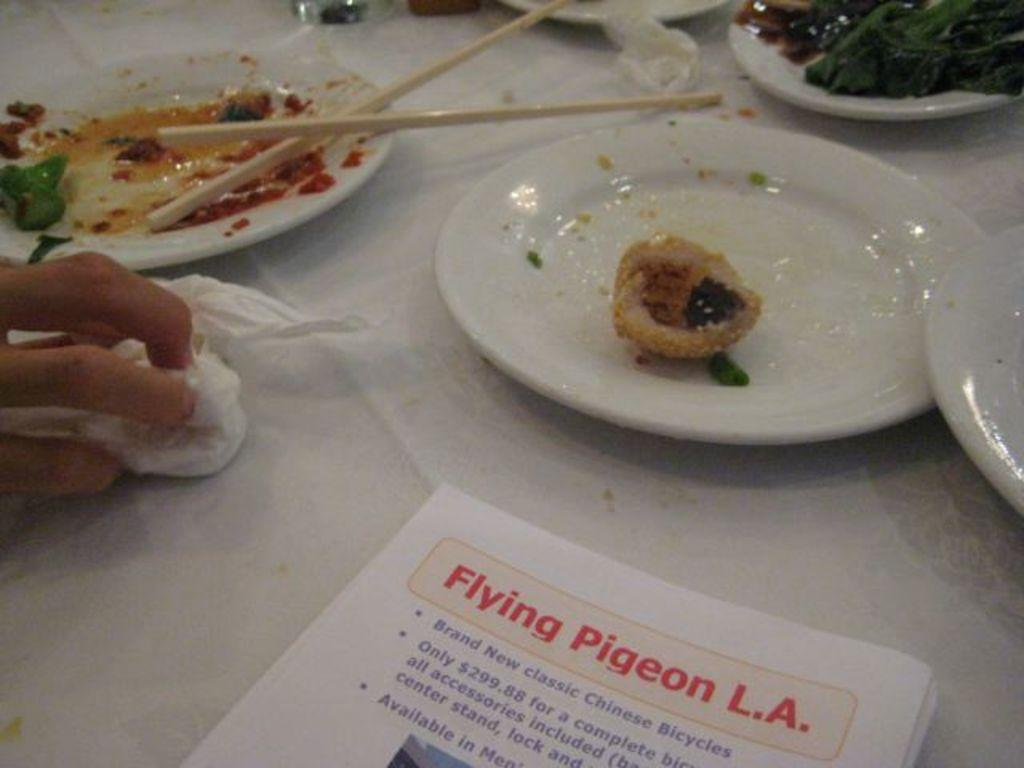What objects are present on the table in the image? There are plates, chopsticks, and papers on the table. What is on the plates in the image? There is food on the plates. What might be used for eating the food on the plates? Chopsticks are present in the image for eating the food. What is the human hand holding in the image? A human hand is holding a napkin on the table. What type of authority is depicted in the image? There is no authority figure present in the image; it features plates, chopsticks, food, papers, and a human hand holding a napkin. What time of day is it in the image, based on the hour? The provided facts do not mention the time of day or any specific hour, so it cannot be determined from the image. 